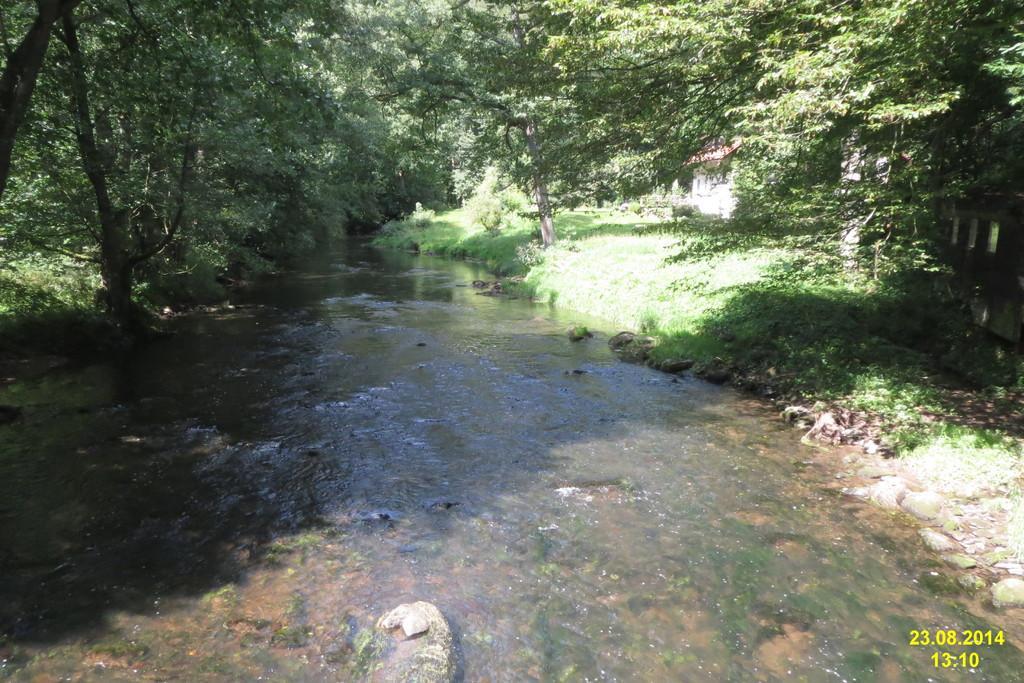In one or two sentences, can you explain what this image depicts? In the image there is some water flowing on a surface, around that water surface there is a lot of grass and trees. 